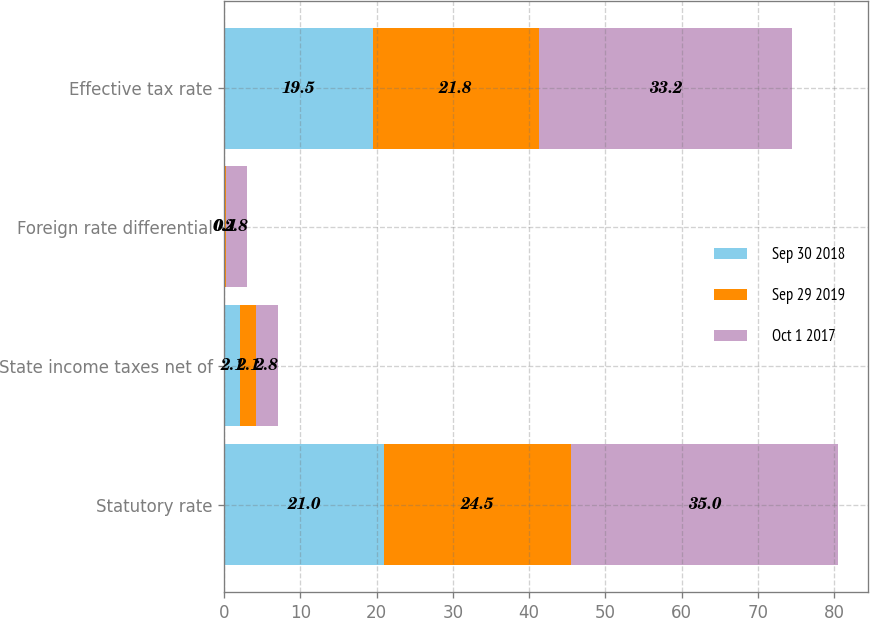Convert chart. <chart><loc_0><loc_0><loc_500><loc_500><stacked_bar_chart><ecel><fcel>Statutory rate<fcel>State income taxes net of<fcel>Foreign rate differential<fcel>Effective tax rate<nl><fcel>Sep 30 2018<fcel>21<fcel>2.1<fcel>0.1<fcel>19.5<nl><fcel>Sep 29 2019<fcel>24.5<fcel>2.1<fcel>0.1<fcel>21.8<nl><fcel>Oct 1 2017<fcel>35<fcel>2.8<fcel>2.8<fcel>33.2<nl></chart> 